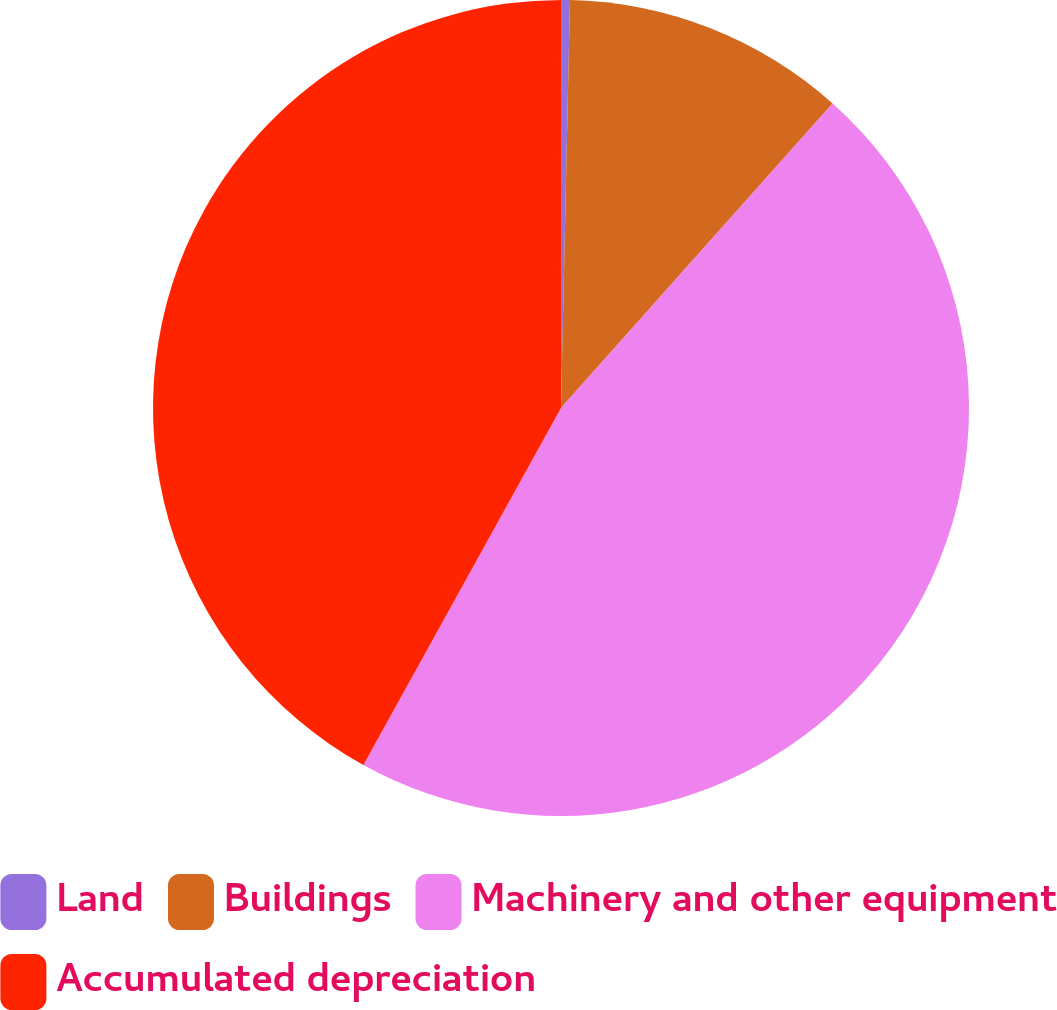<chart> <loc_0><loc_0><loc_500><loc_500><pie_chart><fcel>Land<fcel>Buildings<fcel>Machinery and other equipment<fcel>Accumulated depreciation<nl><fcel>0.35%<fcel>11.24%<fcel>46.45%<fcel>41.95%<nl></chart> 